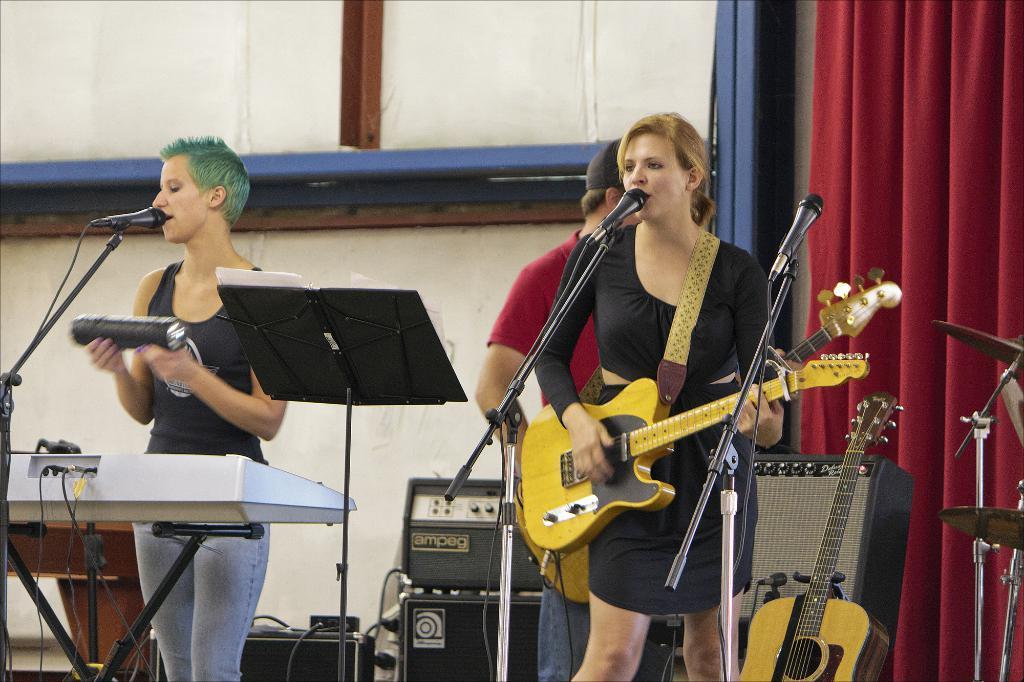Please provide a concise description of this image. This is the picture inside of the room. In this image there are three people. There is a person with black dress is standing and playing guitar and she is singing, other person with blue jeans standing and singing, there is a person with red dress is playing guitar. At the right side of the image there is a curtain, drums, speaker and in the middle of the image there are devices. At the front there are microphones. 